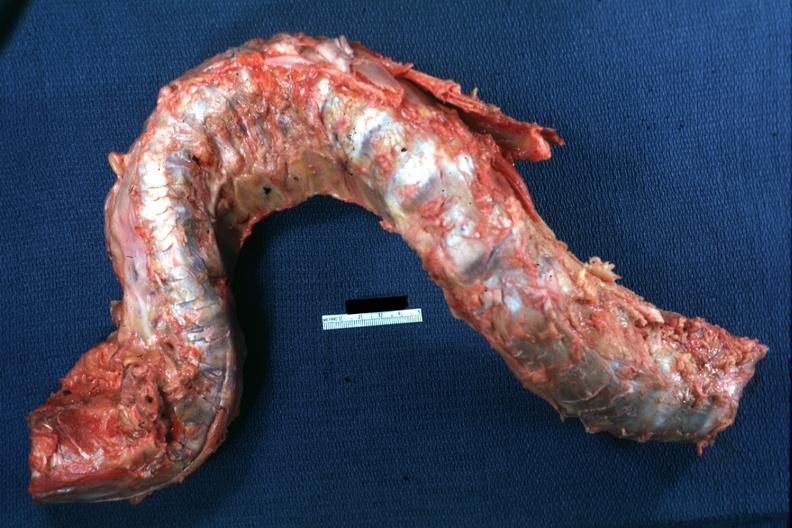s joints present?
Answer the question using a single word or phrase. Yes 